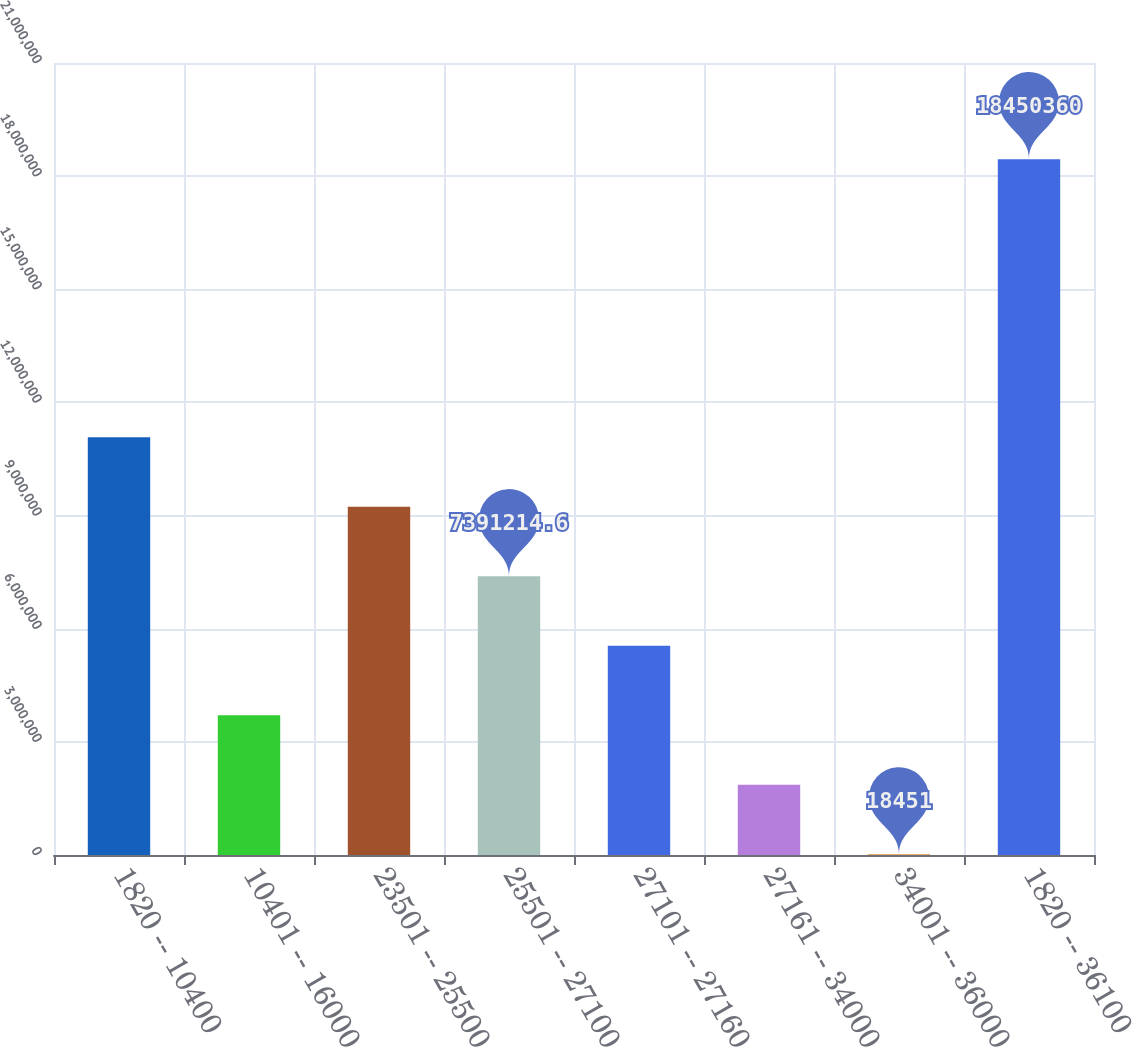Convert chart. <chart><loc_0><loc_0><loc_500><loc_500><bar_chart><fcel>1820 -- 10400<fcel>10401 -- 16000<fcel>23501 -- 25500<fcel>25501 -- 27100<fcel>27101 -- 27160<fcel>27161 -- 34000<fcel>34001 -- 36000<fcel>1820 -- 36100<nl><fcel>1.10776e+07<fcel>3.70483e+06<fcel>9.23441e+06<fcel>7.39121e+06<fcel>5.54802e+06<fcel>1.86164e+06<fcel>18451<fcel>1.84504e+07<nl></chart> 